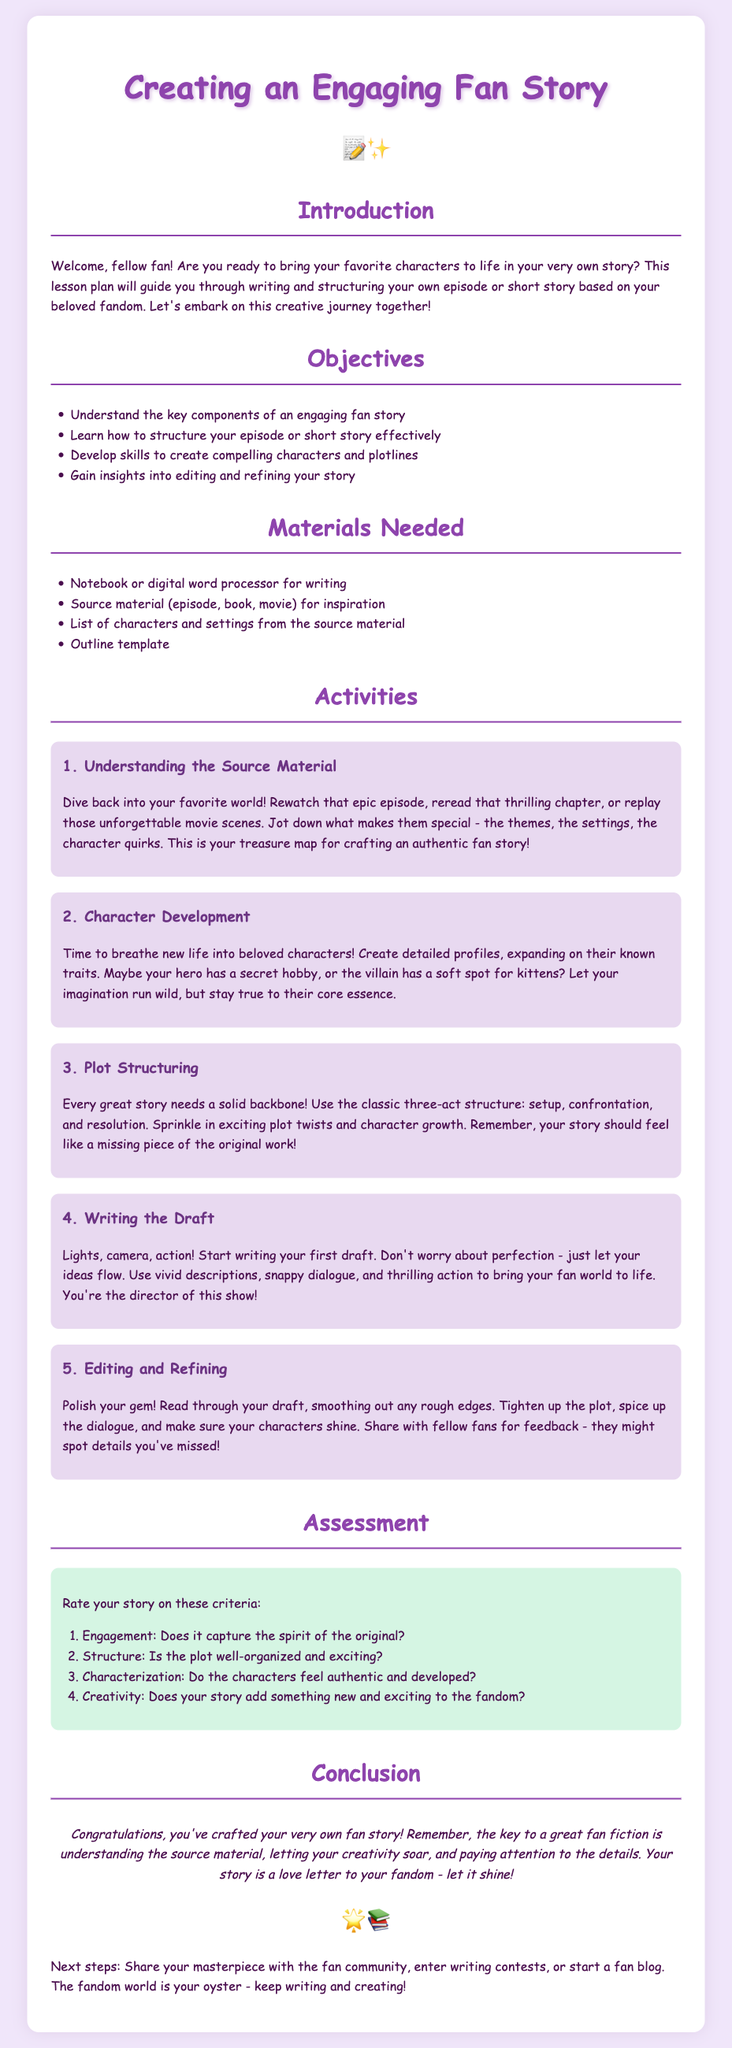what is the title of the lesson plan? The title is prominently displayed at the top of the document, which is "Creating an Engaging Fan Story."
Answer: Creating an Engaging Fan Story how many objectives are listed in the document? The number of objectives can be found under the "Objectives" section where it lists a total of four.
Answer: 4 what is the first activity in the lesson plan? The first activity is described under the "Activities" section and is focused on understanding the source material.
Answer: Understanding the Source Material what writing structure is suggested for the plot? The document specifies using the classic three-act structure for organizing the story.
Answer: three-act structure what criteria is used for assessment in the lesson plan? The assessment section lists four criteria for evaluating the story, focusing on engagement, structure, characterization, and creativity.
Answer: Engagement, Structure, Characterization, Creativity who is the primary audience for this lesson plan? The introductory paragraph hints at the audience by addressing "fellow fans," implying it’s aimed at fans of specific fandoms.
Answer: fellow fans what is the main purpose of the conclusion section? The conclusion summarizes the experience of crafting a fan story and encourages further engagement with the fandom.
Answer: summarizing the experience and encouraging engagement which materials are needed for writing the fan story? The materials needed are listed explicitly in a section dedicated to this purpose.
Answer: Notebook or digital word processor, Source material, List of characters and settings, Outline template what type of style is used in the document's design? The document features a playful and casual design style emphasized by the choice of font and color scheme.
Answer: playful and casual 